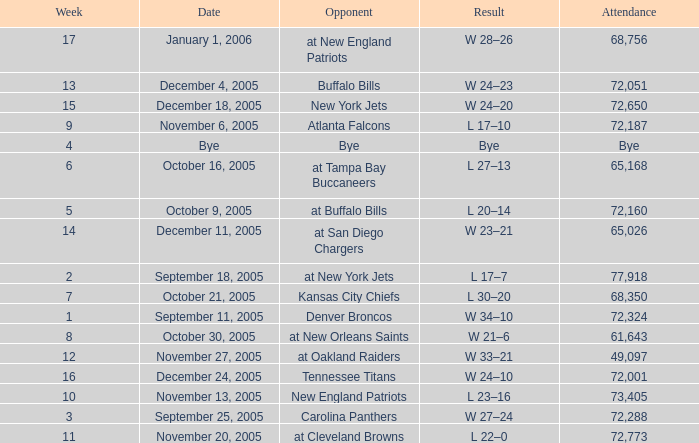In what Week was the Attendance 49,097? 12.0. 